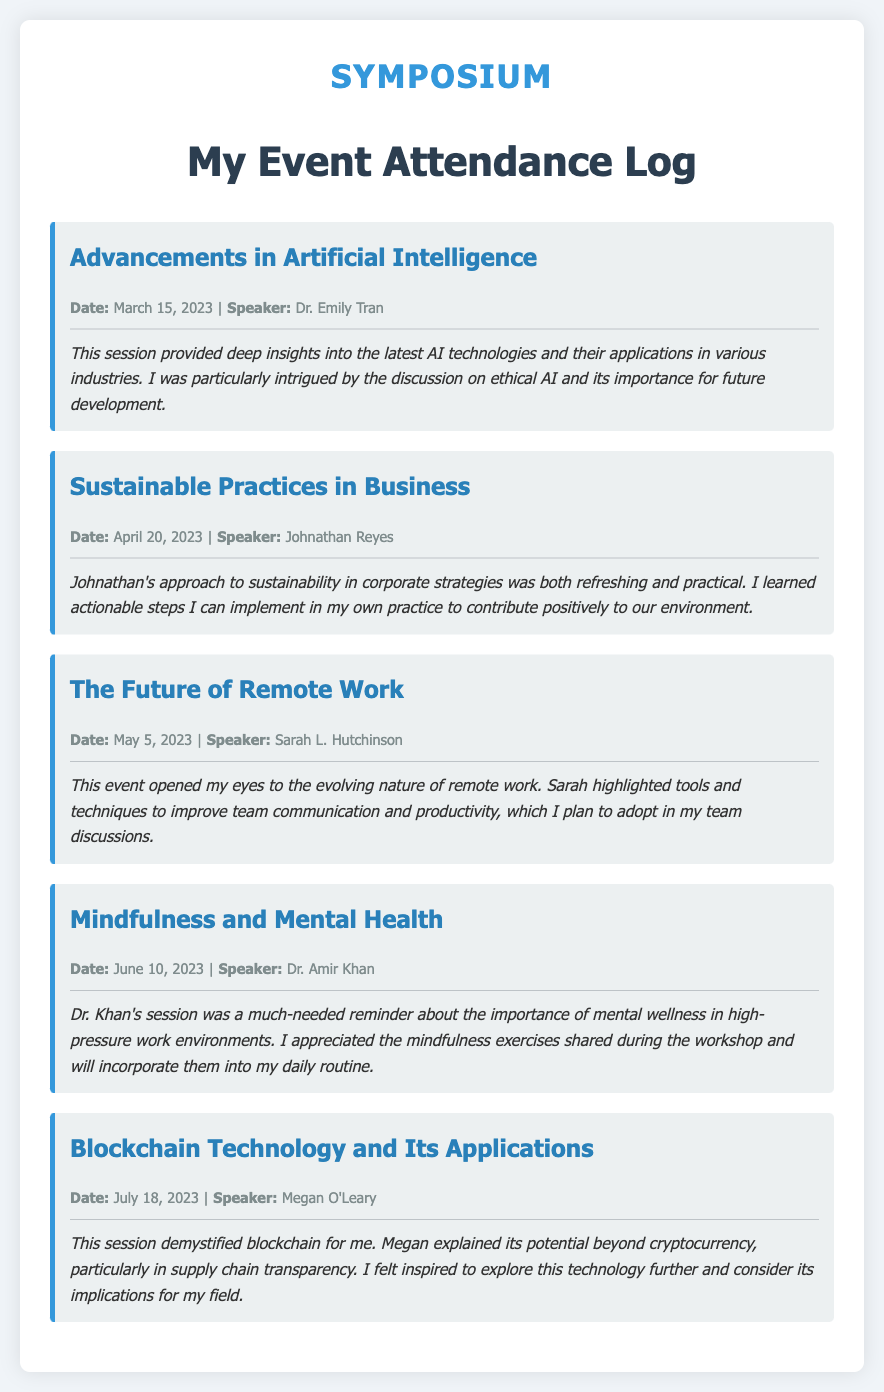What was the date of the "Advancements in Artificial Intelligence" session? The date is specifically mentioned in the event details of that session, which is March 15, 2023.
Answer: March 15, 2023 Who was the speaker for the "Sustainable Practices in Business" event? The speaker's name is presented alongside the event details, which is Johnathan Reyes.
Answer: Johnathan Reyes What topic was covered in the event on May 5, 2023? The topic is listed as "The Future of Remote Work" in the event title.
Answer: The Future of Remote Work Which session emphasized the importance of mental wellness? This aspect of mental wellness is highlighted in the "Mindfulness and Mental Health" session details.
Answer: Mindfulness and Mental Health How many different events are documented in this attendance log? The total number of events listed in the log can be counted from the individual event sections, which are five.
Answer: Five What key theme is mentioned in Dr. Khan's session? The primary theme discussed is the importance of mental wellness in high-pressure environments, as noted in the reflection.
Answer: Mental wellness What is the color of the border on the event sections? The color is specified as a shade of blue used for the border-left of the event sections, which is #3498db.
Answer: Blue Which session included discussion on blockchain technology? The session focused on blockchain technology is titled "Blockchain Technology and Its Applications."
Answer: Blockchain Technology and Its Applications 